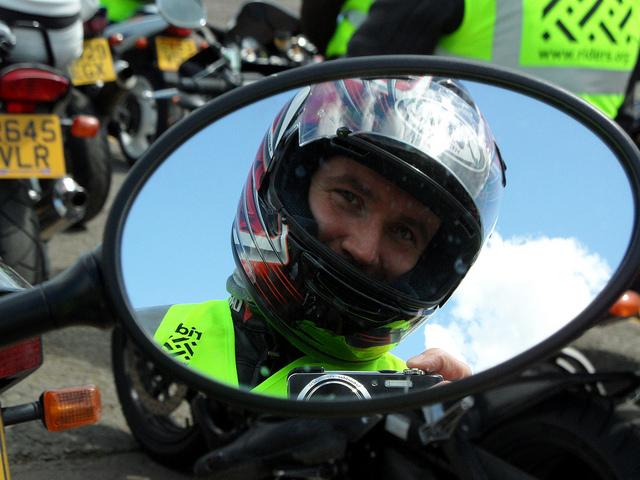What is the man wearing on his head?
Answer briefly. Helmet. Is he taking this pic with a phone or a camera?
Keep it brief. Camera. Is this man's face visible through a reflection?
Concise answer only. Yes. 